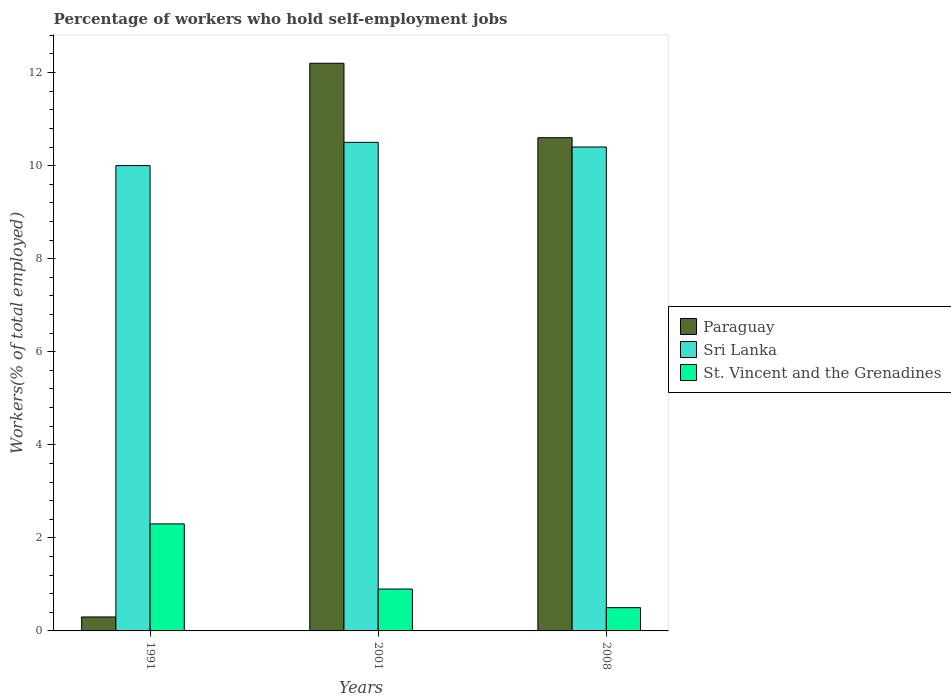Are the number of bars per tick equal to the number of legend labels?
Your answer should be very brief. Yes. Are the number of bars on each tick of the X-axis equal?
Offer a terse response. Yes. How many bars are there on the 2nd tick from the right?
Provide a short and direct response. 3. What is the percentage of self-employed workers in Paraguay in 2001?
Offer a terse response. 12.2. Across all years, what is the maximum percentage of self-employed workers in St. Vincent and the Grenadines?
Your answer should be compact. 2.3. In which year was the percentage of self-employed workers in Sri Lanka minimum?
Give a very brief answer. 1991. What is the total percentage of self-employed workers in Paraguay in the graph?
Ensure brevity in your answer.  23.1. What is the difference between the percentage of self-employed workers in Sri Lanka in 2001 and that in 2008?
Give a very brief answer. 0.1. What is the difference between the percentage of self-employed workers in St. Vincent and the Grenadines in 2008 and the percentage of self-employed workers in Sri Lanka in 2001?
Your answer should be compact. -10. What is the average percentage of self-employed workers in St. Vincent and the Grenadines per year?
Your response must be concise. 1.23. In the year 2008, what is the difference between the percentage of self-employed workers in St. Vincent and the Grenadines and percentage of self-employed workers in Sri Lanka?
Provide a short and direct response. -9.9. What is the ratio of the percentage of self-employed workers in Sri Lanka in 1991 to that in 2008?
Provide a short and direct response. 0.96. What is the difference between the highest and the second highest percentage of self-employed workers in Sri Lanka?
Provide a short and direct response. 0.1. In how many years, is the percentage of self-employed workers in St. Vincent and the Grenadines greater than the average percentage of self-employed workers in St. Vincent and the Grenadines taken over all years?
Keep it short and to the point. 1. What does the 1st bar from the left in 2001 represents?
Offer a very short reply. Paraguay. What does the 1st bar from the right in 2001 represents?
Provide a short and direct response. St. Vincent and the Grenadines. Is it the case that in every year, the sum of the percentage of self-employed workers in St. Vincent and the Grenadines and percentage of self-employed workers in Paraguay is greater than the percentage of self-employed workers in Sri Lanka?
Keep it short and to the point. No. How many bars are there?
Offer a terse response. 9. What is the difference between two consecutive major ticks on the Y-axis?
Give a very brief answer. 2. Are the values on the major ticks of Y-axis written in scientific E-notation?
Give a very brief answer. No. Does the graph contain any zero values?
Ensure brevity in your answer.  No. Where does the legend appear in the graph?
Give a very brief answer. Center right. How are the legend labels stacked?
Give a very brief answer. Vertical. What is the title of the graph?
Give a very brief answer. Percentage of workers who hold self-employment jobs. Does "Mexico" appear as one of the legend labels in the graph?
Offer a terse response. No. What is the label or title of the X-axis?
Provide a short and direct response. Years. What is the label or title of the Y-axis?
Ensure brevity in your answer.  Workers(% of total employed). What is the Workers(% of total employed) of Paraguay in 1991?
Provide a succinct answer. 0.3. What is the Workers(% of total employed) of Sri Lanka in 1991?
Offer a terse response. 10. What is the Workers(% of total employed) of St. Vincent and the Grenadines in 1991?
Make the answer very short. 2.3. What is the Workers(% of total employed) in Paraguay in 2001?
Keep it short and to the point. 12.2. What is the Workers(% of total employed) of Sri Lanka in 2001?
Ensure brevity in your answer.  10.5. What is the Workers(% of total employed) of St. Vincent and the Grenadines in 2001?
Your response must be concise. 0.9. What is the Workers(% of total employed) of Paraguay in 2008?
Offer a very short reply. 10.6. What is the Workers(% of total employed) in Sri Lanka in 2008?
Provide a succinct answer. 10.4. What is the Workers(% of total employed) of St. Vincent and the Grenadines in 2008?
Give a very brief answer. 0.5. Across all years, what is the maximum Workers(% of total employed) of Paraguay?
Ensure brevity in your answer.  12.2. Across all years, what is the maximum Workers(% of total employed) in St. Vincent and the Grenadines?
Your response must be concise. 2.3. Across all years, what is the minimum Workers(% of total employed) of Paraguay?
Your answer should be very brief. 0.3. Across all years, what is the minimum Workers(% of total employed) of St. Vincent and the Grenadines?
Give a very brief answer. 0.5. What is the total Workers(% of total employed) of Paraguay in the graph?
Your response must be concise. 23.1. What is the total Workers(% of total employed) of Sri Lanka in the graph?
Provide a succinct answer. 30.9. What is the difference between the Workers(% of total employed) in Paraguay in 1991 and that in 2001?
Your response must be concise. -11.9. What is the difference between the Workers(% of total employed) in St. Vincent and the Grenadines in 1991 and that in 2001?
Your answer should be compact. 1.4. What is the difference between the Workers(% of total employed) in Paraguay in 2001 and that in 2008?
Your answer should be very brief. 1.6. What is the difference between the Workers(% of total employed) in St. Vincent and the Grenadines in 2001 and that in 2008?
Keep it short and to the point. 0.4. What is the difference between the Workers(% of total employed) of Paraguay in 1991 and the Workers(% of total employed) of Sri Lanka in 2008?
Your answer should be compact. -10.1. What is the difference between the Workers(% of total employed) in Paraguay in 1991 and the Workers(% of total employed) in St. Vincent and the Grenadines in 2008?
Offer a terse response. -0.2. What is the difference between the Workers(% of total employed) in Sri Lanka in 1991 and the Workers(% of total employed) in St. Vincent and the Grenadines in 2008?
Make the answer very short. 9.5. What is the difference between the Workers(% of total employed) of Paraguay in 2001 and the Workers(% of total employed) of Sri Lanka in 2008?
Offer a terse response. 1.8. What is the average Workers(% of total employed) of St. Vincent and the Grenadines per year?
Your response must be concise. 1.23. In the year 1991, what is the difference between the Workers(% of total employed) of Paraguay and Workers(% of total employed) of Sri Lanka?
Offer a terse response. -9.7. In the year 1991, what is the difference between the Workers(% of total employed) in Paraguay and Workers(% of total employed) in St. Vincent and the Grenadines?
Offer a terse response. -2. In the year 2001, what is the difference between the Workers(% of total employed) in Paraguay and Workers(% of total employed) in St. Vincent and the Grenadines?
Offer a very short reply. 11.3. In the year 2008, what is the difference between the Workers(% of total employed) in Paraguay and Workers(% of total employed) in St. Vincent and the Grenadines?
Your answer should be compact. 10.1. In the year 2008, what is the difference between the Workers(% of total employed) of Sri Lanka and Workers(% of total employed) of St. Vincent and the Grenadines?
Offer a terse response. 9.9. What is the ratio of the Workers(% of total employed) of Paraguay in 1991 to that in 2001?
Make the answer very short. 0.02. What is the ratio of the Workers(% of total employed) of St. Vincent and the Grenadines in 1991 to that in 2001?
Ensure brevity in your answer.  2.56. What is the ratio of the Workers(% of total employed) of Paraguay in 1991 to that in 2008?
Offer a terse response. 0.03. What is the ratio of the Workers(% of total employed) in Sri Lanka in 1991 to that in 2008?
Ensure brevity in your answer.  0.96. What is the ratio of the Workers(% of total employed) of St. Vincent and the Grenadines in 1991 to that in 2008?
Give a very brief answer. 4.6. What is the ratio of the Workers(% of total employed) of Paraguay in 2001 to that in 2008?
Your answer should be very brief. 1.15. What is the ratio of the Workers(% of total employed) of Sri Lanka in 2001 to that in 2008?
Offer a terse response. 1.01. What is the difference between the highest and the lowest Workers(% of total employed) of Sri Lanka?
Offer a terse response. 0.5. 